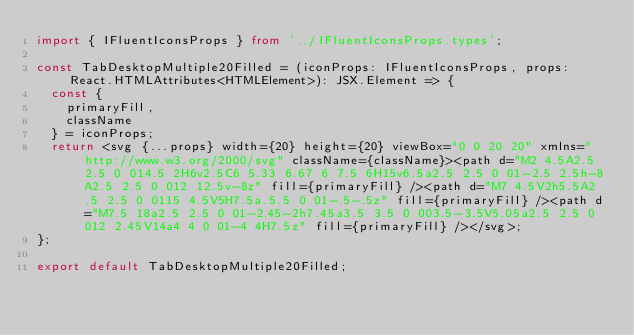Convert code to text. <code><loc_0><loc_0><loc_500><loc_500><_TypeScript_>import { IFluentIconsProps } from '../IFluentIconsProps.types';

const TabDesktopMultiple20Filled = (iconProps: IFluentIconsProps, props: React.HTMLAttributes<HTMLElement>): JSX.Element => {
  const {
    primaryFill,
    className
  } = iconProps;
  return <svg {...props} width={20} height={20} viewBox="0 0 20 20" xmlns="http://www.w3.org/2000/svg" className={className}><path d="M2 4.5A2.5 2.5 0 014.5 2H6v2.5C6 5.33 6.67 6 7.5 6H15v6.5a2.5 2.5 0 01-2.5 2.5h-8A2.5 2.5 0 012 12.5v-8z" fill={primaryFill} /><path d="M7 4.5V2h5.5A2.5 2.5 0 0115 4.5V5H7.5a.5.5 0 01-.5-.5z" fill={primaryFill} /><path d="M7.5 18a2.5 2.5 0 01-2.45-2h7.45a3.5 3.5 0 003.5-3.5V5.05a2.5 2.5 0 012 2.45V14a4 4 0 01-4 4H7.5z" fill={primaryFill} /></svg>;
};

export default TabDesktopMultiple20Filled;</code> 